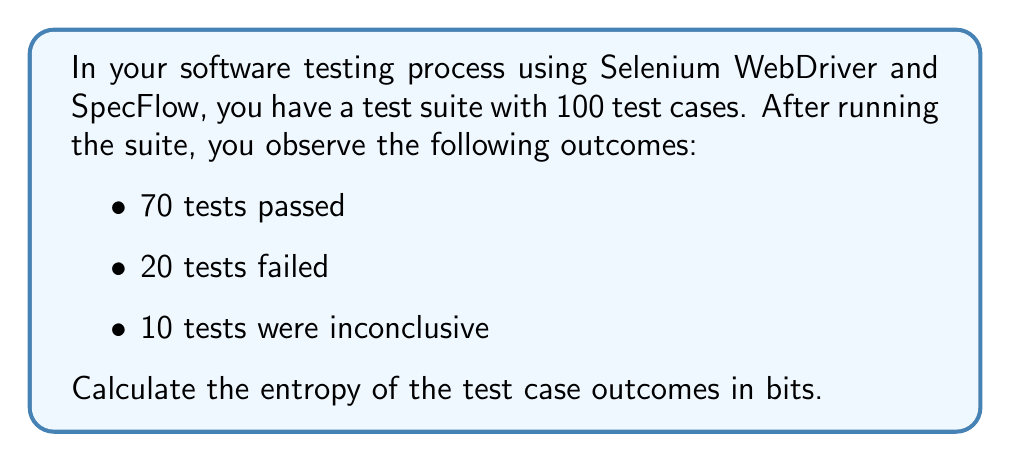Give your solution to this math problem. To calculate the entropy of the test case outcomes, we'll use the formula for Shannon entropy:

$$H = -\sum_{i=1}^{n} p_i \log_2(p_i)$$

Where:
- $H$ is the entropy in bits
- $p_i$ is the probability of each outcome
- $n$ is the number of possible outcomes

Step 1: Calculate the probabilities for each outcome:
- $p_{pass} = 70/100 = 0.7$
- $p_{fail} = 20/100 = 0.2$
- $p_{inconclusive} = 10/100 = 0.1$

Step 2: Apply the entropy formula:

$$\begin{align*}
H &= -(p_{pass} \log_2(p_{pass}) + p_{fail} \log_2(p_{fail}) + p_{inconclusive} \log_2(p_{inconclusive})) \\
&= -(0.7 \log_2(0.7) + 0.2 \log_2(0.2) + 0.1 \log_2(0.1))
\end{align*}$$

Step 3: Calculate each term:
- $0.7 \log_2(0.7) \approx -0.3600$
- $0.2 \log_2(0.2) \approx -0.4644$
- $0.1 \log_2(0.1) \approx -0.3322$

Step 4: Sum the terms and take the negative:

$$H = -(-0.3600 - 0.4644 - 0.3322) \approx 1.1566$$

Therefore, the entropy of the test case outcomes is approximately 1.1566 bits.
Answer: The entropy of the test case outcomes is approximately 1.1566 bits. 